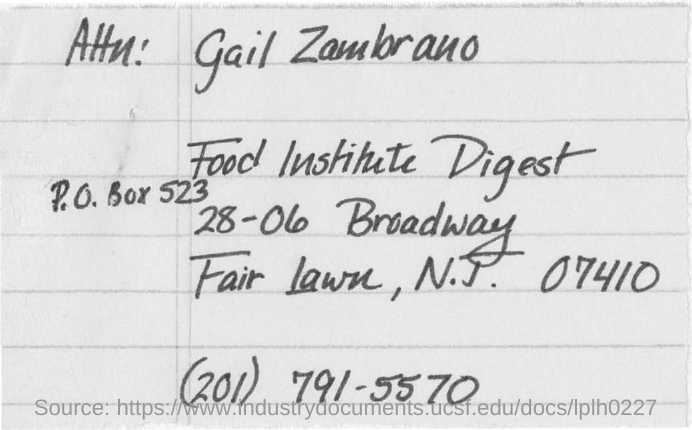What is the P.O.Box no given?
Your answer should be very brief. P.O. Box 523. 